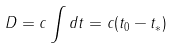<formula> <loc_0><loc_0><loc_500><loc_500>D = c \int d t = c ( t _ { 0 } - t _ { * } )</formula> 